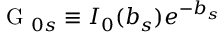Convert formula to latex. <formula><loc_0><loc_0><loc_500><loc_500>G _ { 0 s } \equiv I _ { 0 } ( b _ { s } ) e ^ { - b _ { s } }</formula> 